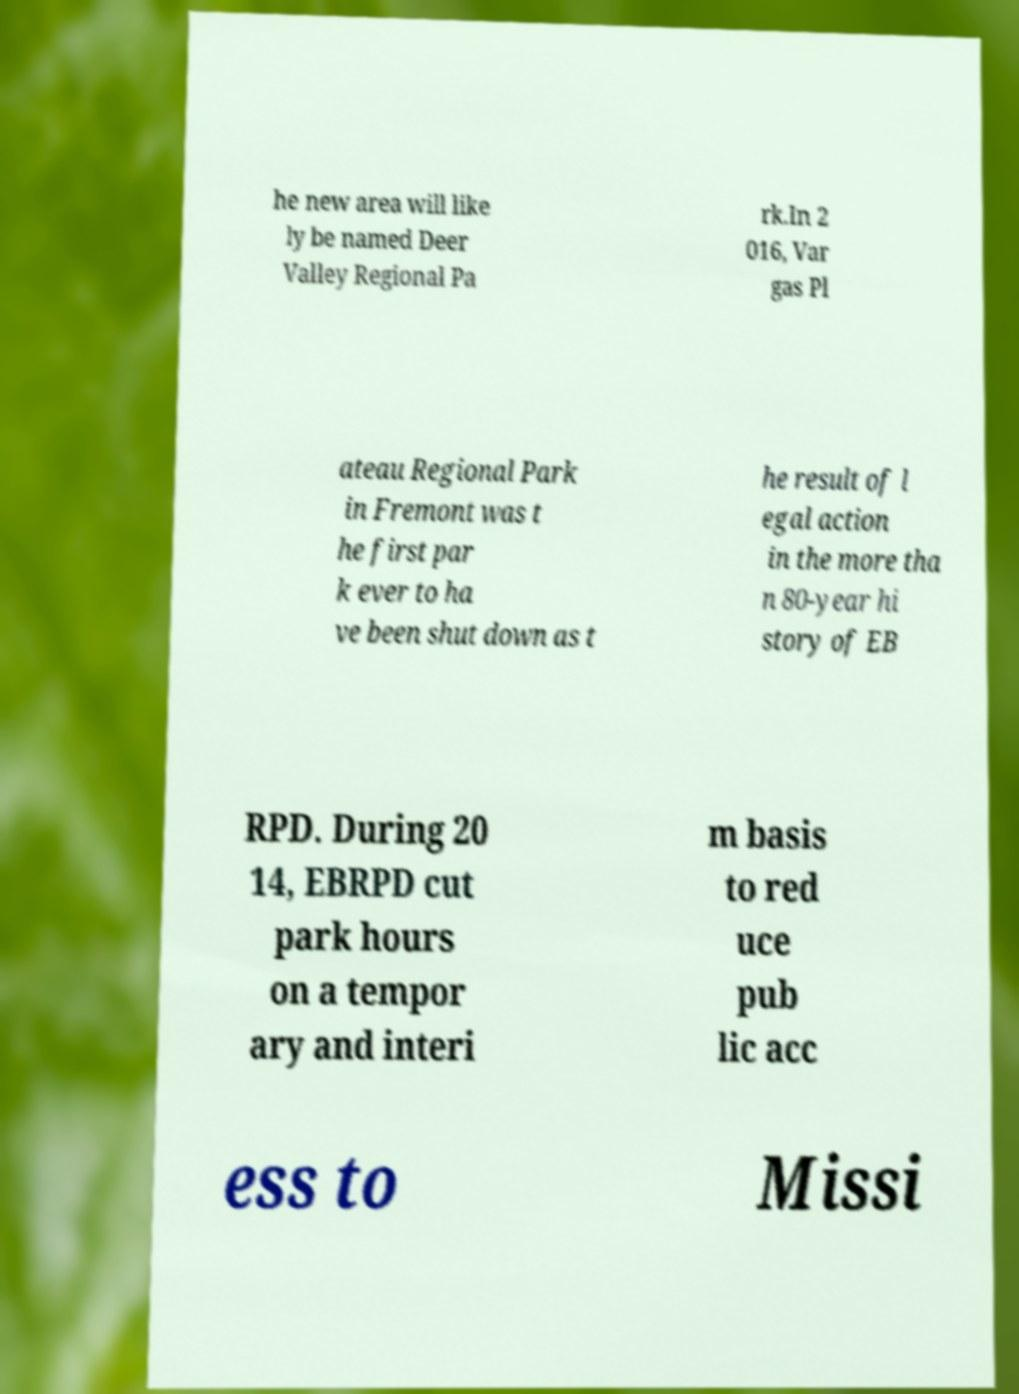I need the written content from this picture converted into text. Can you do that? he new area will like ly be named Deer Valley Regional Pa rk.In 2 016, Var gas Pl ateau Regional Park in Fremont was t he first par k ever to ha ve been shut down as t he result of l egal action in the more tha n 80-year hi story of EB RPD. During 20 14, EBRPD cut park hours on a tempor ary and interi m basis to red uce pub lic acc ess to Missi 